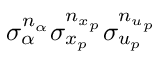Convert formula to latex. <formula><loc_0><loc_0><loc_500><loc_500>\sigma _ { \alpha } ^ { n _ { \alpha } } \sigma _ { x _ { p } } ^ { n _ { x _ { p } } } \sigma _ { u _ { p } } ^ { n _ { u _ { p } } }</formula> 